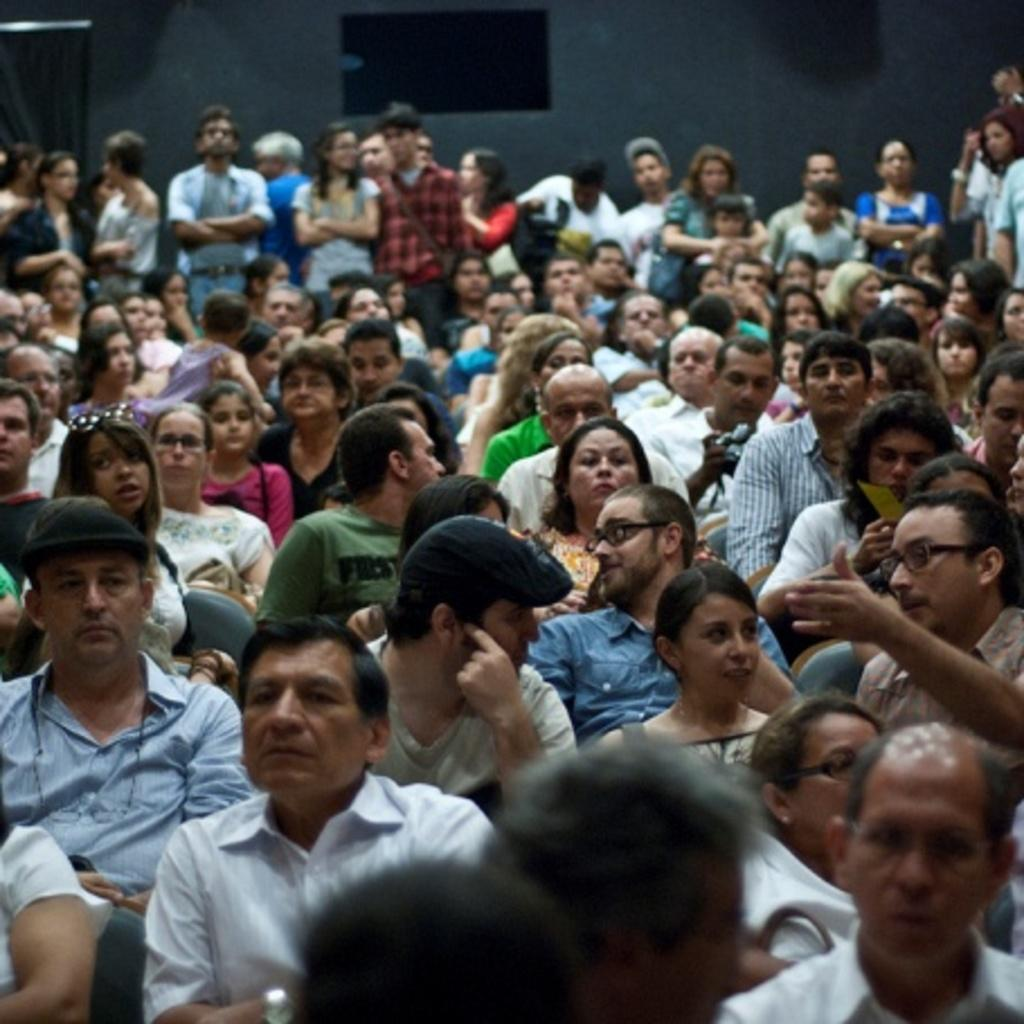What are the people in the center of the image doing? There are many people sitting on chairs in the center of the image. What is happening in the background of the image? There are people standing in the background of the image. What can be seen behind the people in the background? There is a wall visible in the background of the image. What type of card is being discussed by the committee in the image? There is no committee or card present in the image. What substance is being used by the people in the image? The provided facts do not mention any substances being used by the people in the image. 